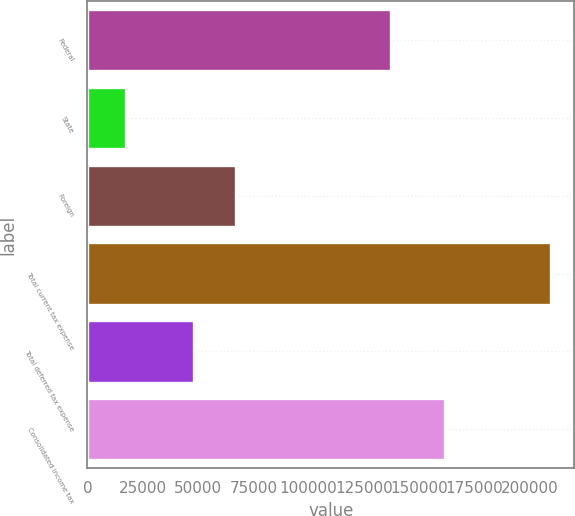Convert chart. <chart><loc_0><loc_0><loc_500><loc_500><bar_chart><fcel>Federal<fcel>State<fcel>Foreign<fcel>Total current tax expense<fcel>Total deferred tax expense<fcel>Consolidated income tax<nl><fcel>137136<fcel>17563<fcel>67204.8<fcel>209521<fcel>48009<fcel>161512<nl></chart> 